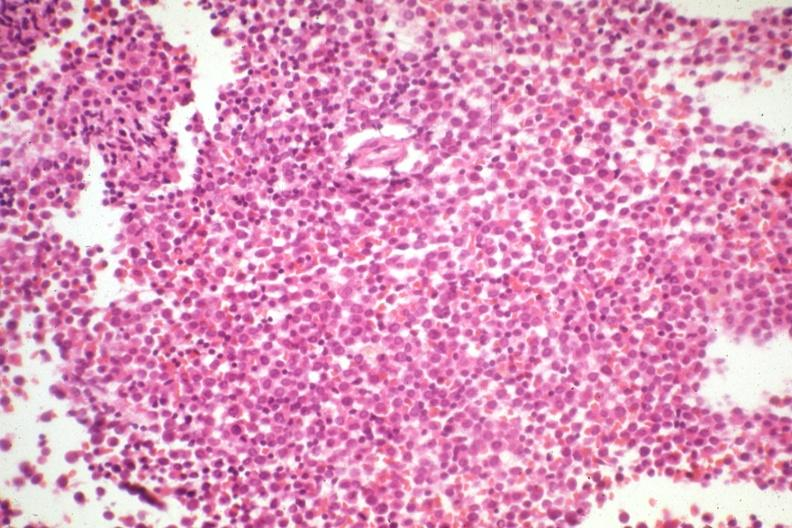s hematologic present?
Answer the question using a single word or phrase. Yes 